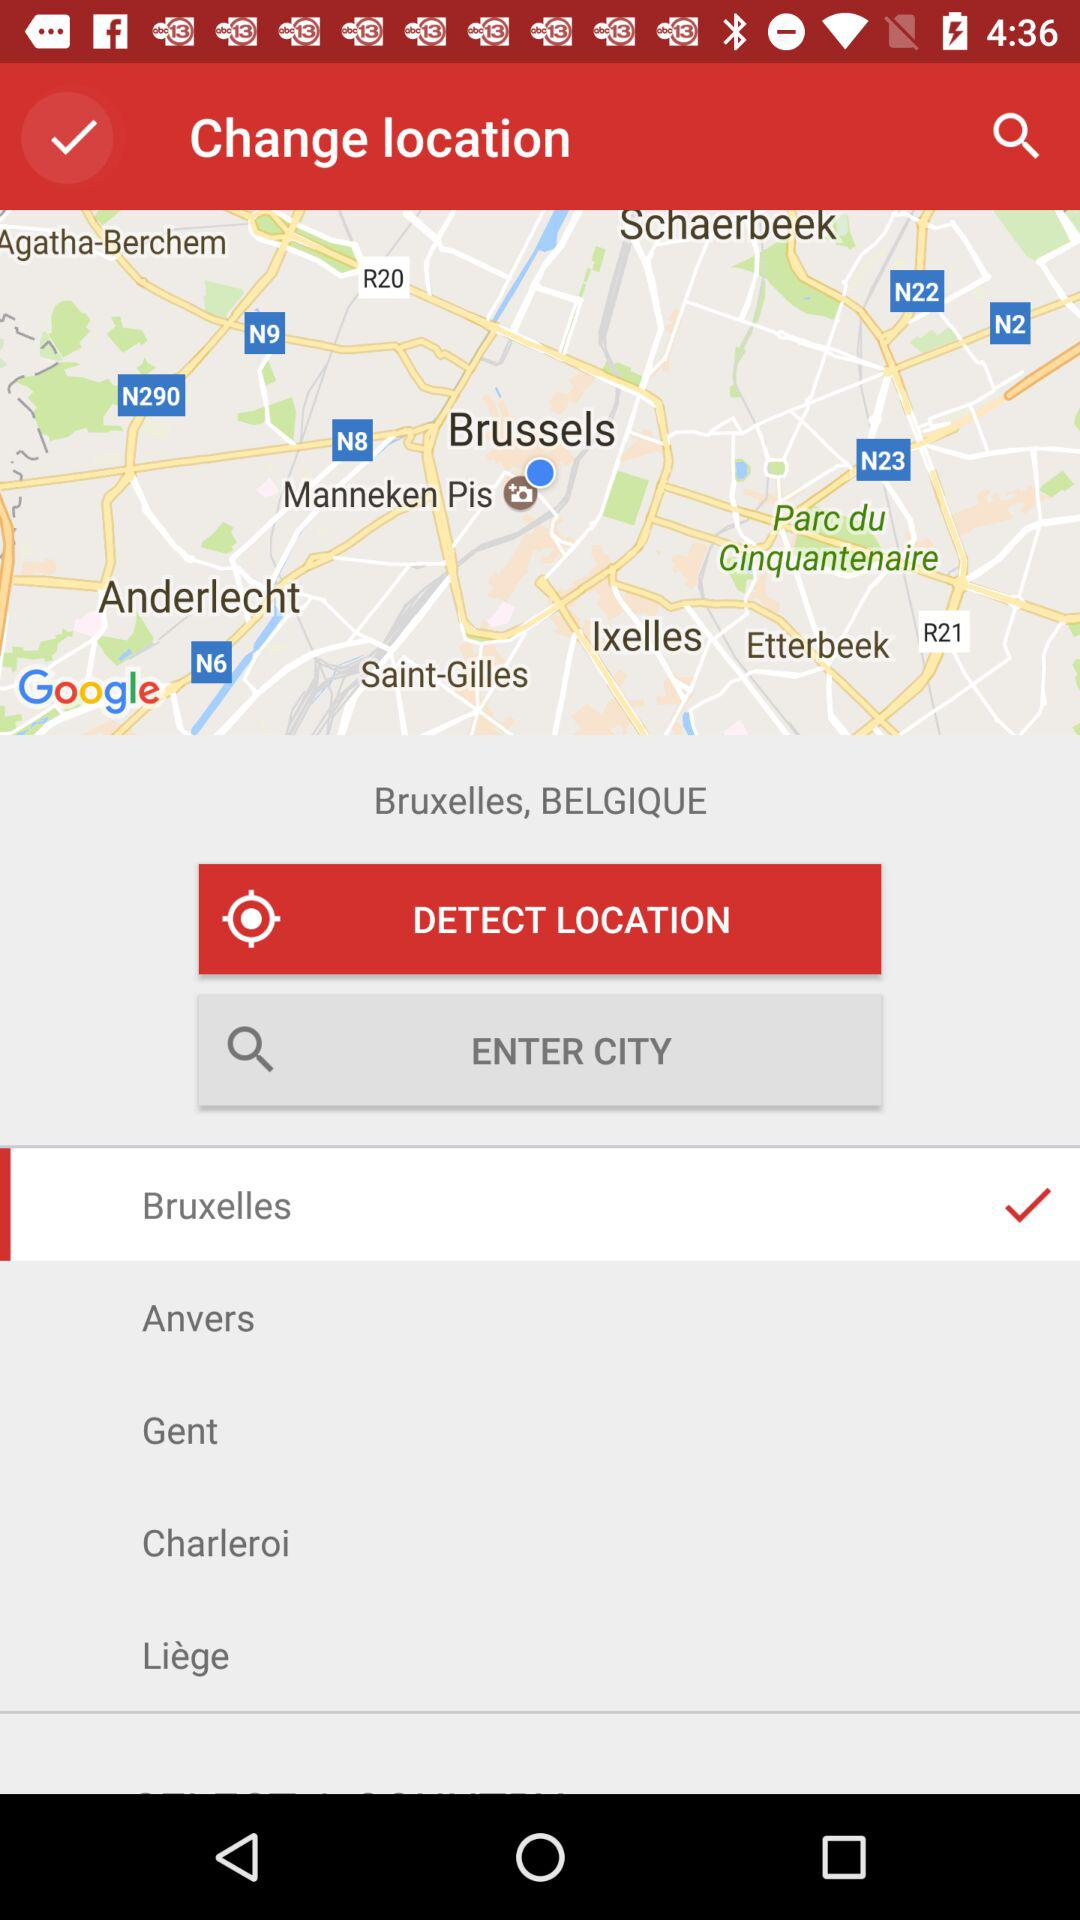Which location has been selected? The location that has been selected is "Bruxelles". 